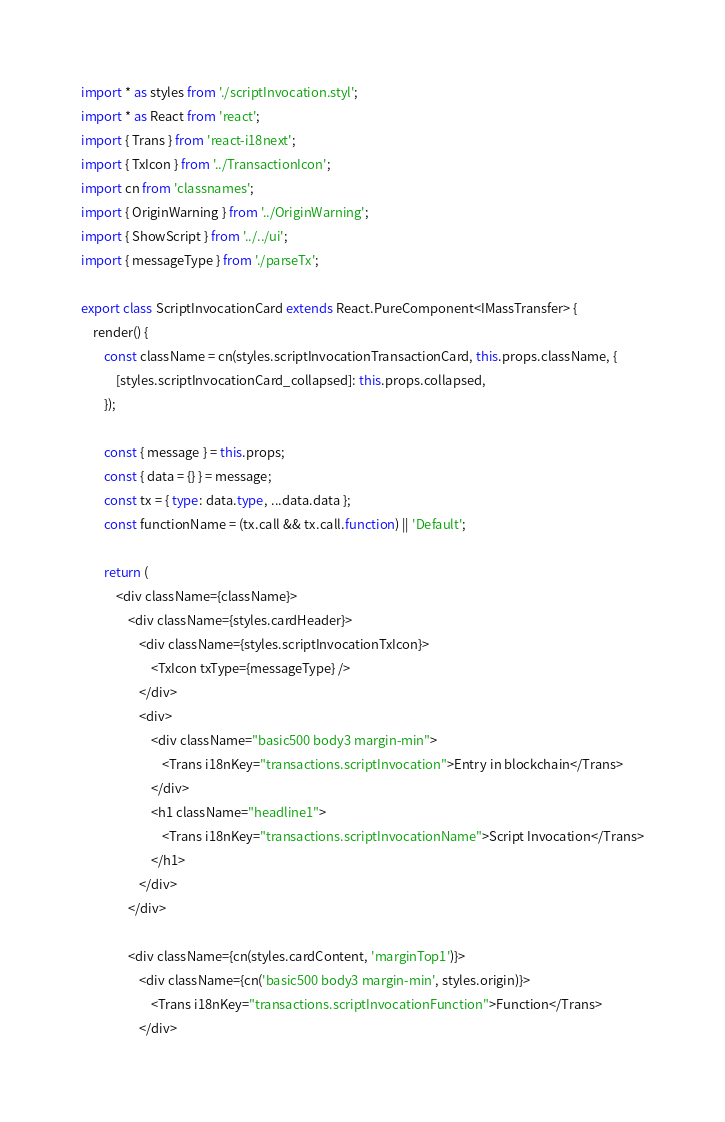Convert code to text. <code><loc_0><loc_0><loc_500><loc_500><_TypeScript_>import * as styles from './scriptInvocation.styl';
import * as React from 'react';
import { Trans } from 'react-i18next';
import { TxIcon } from '../TransactionIcon';
import cn from 'classnames';
import { OriginWarning } from '../OriginWarning';
import { ShowScript } from '../../ui';
import { messageType } from './parseTx';

export class ScriptInvocationCard extends React.PureComponent<IMassTransfer> {
    render() {
        const className = cn(styles.scriptInvocationTransactionCard, this.props.className, {
            [styles.scriptInvocationCard_collapsed]: this.props.collapsed,
        });

        const { message } = this.props;
        const { data = {} } = message;
        const tx = { type: data.type, ...data.data };
        const functionName = (tx.call && tx.call.function) || 'Default';

        return (
            <div className={className}>
                <div className={styles.cardHeader}>
                    <div className={styles.scriptInvocationTxIcon}>
                        <TxIcon txType={messageType} />
                    </div>
                    <div>
                        <div className="basic500 body3 margin-min">
                            <Trans i18nKey="transactions.scriptInvocation">Entry in blockchain</Trans>
                        </div>
                        <h1 className="headline1">
                            <Trans i18nKey="transactions.scriptInvocationName">Script Invocation</Trans>
                        </h1>
                    </div>
                </div>

                <div className={cn(styles.cardContent, 'marginTop1')}>
                    <div className={cn('basic500 body3 margin-min', styles.origin)}>
                        <Trans i18nKey="transactions.scriptInvocationFunction">Function</Trans>
                    </div></code> 